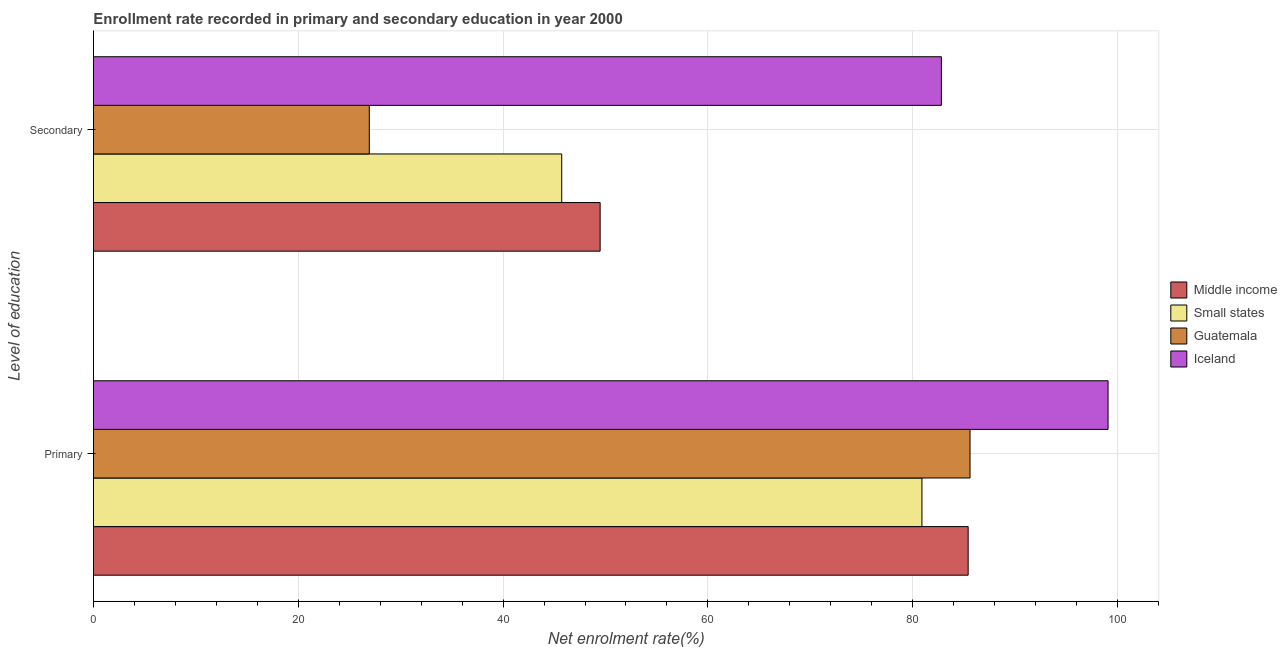Are the number of bars per tick equal to the number of legend labels?
Provide a short and direct response. Yes. Are the number of bars on each tick of the Y-axis equal?
Your response must be concise. Yes. What is the label of the 1st group of bars from the top?
Your answer should be very brief. Secondary. What is the enrollment rate in primary education in Guatemala?
Offer a very short reply. 85.6. Across all countries, what is the maximum enrollment rate in primary education?
Ensure brevity in your answer.  99.08. Across all countries, what is the minimum enrollment rate in primary education?
Make the answer very short. 80.9. In which country was the enrollment rate in secondary education minimum?
Offer a very short reply. Guatemala. What is the total enrollment rate in primary education in the graph?
Provide a succinct answer. 350.99. What is the difference between the enrollment rate in primary education in Small states and that in Iceland?
Offer a terse response. -18.17. What is the difference between the enrollment rate in secondary education in Middle income and the enrollment rate in primary education in Guatemala?
Keep it short and to the point. -36.12. What is the average enrollment rate in primary education per country?
Give a very brief answer. 87.75. What is the difference between the enrollment rate in primary education and enrollment rate in secondary education in Middle income?
Make the answer very short. 35.94. What is the ratio of the enrollment rate in primary education in Small states to that in Guatemala?
Make the answer very short. 0.95. In how many countries, is the enrollment rate in secondary education greater than the average enrollment rate in secondary education taken over all countries?
Make the answer very short. 1. What does the 2nd bar from the bottom in Primary represents?
Your answer should be compact. Small states. How many bars are there?
Provide a short and direct response. 8. What is the difference between two consecutive major ticks on the X-axis?
Keep it short and to the point. 20. Are the values on the major ticks of X-axis written in scientific E-notation?
Provide a short and direct response. No. Does the graph contain any zero values?
Provide a succinct answer. No. How are the legend labels stacked?
Offer a terse response. Vertical. What is the title of the graph?
Offer a very short reply. Enrollment rate recorded in primary and secondary education in year 2000. Does "Kiribati" appear as one of the legend labels in the graph?
Make the answer very short. No. What is the label or title of the X-axis?
Provide a short and direct response. Net enrolment rate(%). What is the label or title of the Y-axis?
Ensure brevity in your answer.  Level of education. What is the Net enrolment rate(%) in Middle income in Primary?
Give a very brief answer. 85.41. What is the Net enrolment rate(%) of Small states in Primary?
Your response must be concise. 80.9. What is the Net enrolment rate(%) of Guatemala in Primary?
Your answer should be very brief. 85.6. What is the Net enrolment rate(%) in Iceland in Primary?
Offer a terse response. 99.08. What is the Net enrolment rate(%) in Middle income in Secondary?
Provide a short and direct response. 49.48. What is the Net enrolment rate(%) in Small states in Secondary?
Your answer should be compact. 45.72. What is the Net enrolment rate(%) in Guatemala in Secondary?
Provide a succinct answer. 26.94. What is the Net enrolment rate(%) in Iceland in Secondary?
Keep it short and to the point. 82.8. Across all Level of education, what is the maximum Net enrolment rate(%) in Middle income?
Keep it short and to the point. 85.41. Across all Level of education, what is the maximum Net enrolment rate(%) in Small states?
Your answer should be very brief. 80.9. Across all Level of education, what is the maximum Net enrolment rate(%) in Guatemala?
Ensure brevity in your answer.  85.6. Across all Level of education, what is the maximum Net enrolment rate(%) in Iceland?
Provide a short and direct response. 99.08. Across all Level of education, what is the minimum Net enrolment rate(%) of Middle income?
Give a very brief answer. 49.48. Across all Level of education, what is the minimum Net enrolment rate(%) of Small states?
Keep it short and to the point. 45.72. Across all Level of education, what is the minimum Net enrolment rate(%) of Guatemala?
Give a very brief answer. 26.94. Across all Level of education, what is the minimum Net enrolment rate(%) in Iceland?
Your answer should be very brief. 82.8. What is the total Net enrolment rate(%) of Middle income in the graph?
Your answer should be very brief. 134.89. What is the total Net enrolment rate(%) of Small states in the graph?
Your answer should be very brief. 126.63. What is the total Net enrolment rate(%) in Guatemala in the graph?
Offer a very short reply. 112.53. What is the total Net enrolment rate(%) in Iceland in the graph?
Offer a terse response. 181.88. What is the difference between the Net enrolment rate(%) of Middle income in Primary and that in Secondary?
Your response must be concise. 35.94. What is the difference between the Net enrolment rate(%) of Small states in Primary and that in Secondary?
Ensure brevity in your answer.  35.18. What is the difference between the Net enrolment rate(%) of Guatemala in Primary and that in Secondary?
Offer a terse response. 58.66. What is the difference between the Net enrolment rate(%) in Iceland in Primary and that in Secondary?
Offer a terse response. 16.28. What is the difference between the Net enrolment rate(%) of Middle income in Primary and the Net enrolment rate(%) of Small states in Secondary?
Your answer should be compact. 39.69. What is the difference between the Net enrolment rate(%) in Middle income in Primary and the Net enrolment rate(%) in Guatemala in Secondary?
Your answer should be very brief. 58.48. What is the difference between the Net enrolment rate(%) in Middle income in Primary and the Net enrolment rate(%) in Iceland in Secondary?
Your answer should be very brief. 2.61. What is the difference between the Net enrolment rate(%) in Small states in Primary and the Net enrolment rate(%) in Guatemala in Secondary?
Provide a succinct answer. 53.97. What is the difference between the Net enrolment rate(%) in Small states in Primary and the Net enrolment rate(%) in Iceland in Secondary?
Ensure brevity in your answer.  -1.9. What is the difference between the Net enrolment rate(%) in Guatemala in Primary and the Net enrolment rate(%) in Iceland in Secondary?
Keep it short and to the point. 2.8. What is the average Net enrolment rate(%) of Middle income per Level of education?
Provide a succinct answer. 67.45. What is the average Net enrolment rate(%) in Small states per Level of education?
Provide a short and direct response. 63.31. What is the average Net enrolment rate(%) of Guatemala per Level of education?
Ensure brevity in your answer.  56.27. What is the average Net enrolment rate(%) in Iceland per Level of education?
Ensure brevity in your answer.  90.94. What is the difference between the Net enrolment rate(%) of Middle income and Net enrolment rate(%) of Small states in Primary?
Give a very brief answer. 4.51. What is the difference between the Net enrolment rate(%) of Middle income and Net enrolment rate(%) of Guatemala in Primary?
Offer a terse response. -0.18. What is the difference between the Net enrolment rate(%) of Middle income and Net enrolment rate(%) of Iceland in Primary?
Make the answer very short. -13.66. What is the difference between the Net enrolment rate(%) of Small states and Net enrolment rate(%) of Guatemala in Primary?
Your response must be concise. -4.7. What is the difference between the Net enrolment rate(%) in Small states and Net enrolment rate(%) in Iceland in Primary?
Provide a succinct answer. -18.17. What is the difference between the Net enrolment rate(%) in Guatemala and Net enrolment rate(%) in Iceland in Primary?
Offer a terse response. -13.48. What is the difference between the Net enrolment rate(%) of Middle income and Net enrolment rate(%) of Small states in Secondary?
Give a very brief answer. 3.75. What is the difference between the Net enrolment rate(%) in Middle income and Net enrolment rate(%) in Guatemala in Secondary?
Offer a very short reply. 22.54. What is the difference between the Net enrolment rate(%) of Middle income and Net enrolment rate(%) of Iceland in Secondary?
Offer a terse response. -33.32. What is the difference between the Net enrolment rate(%) in Small states and Net enrolment rate(%) in Guatemala in Secondary?
Offer a terse response. 18.79. What is the difference between the Net enrolment rate(%) in Small states and Net enrolment rate(%) in Iceland in Secondary?
Provide a succinct answer. -37.08. What is the difference between the Net enrolment rate(%) of Guatemala and Net enrolment rate(%) of Iceland in Secondary?
Your response must be concise. -55.86. What is the ratio of the Net enrolment rate(%) of Middle income in Primary to that in Secondary?
Your response must be concise. 1.73. What is the ratio of the Net enrolment rate(%) of Small states in Primary to that in Secondary?
Offer a terse response. 1.77. What is the ratio of the Net enrolment rate(%) in Guatemala in Primary to that in Secondary?
Ensure brevity in your answer.  3.18. What is the ratio of the Net enrolment rate(%) in Iceland in Primary to that in Secondary?
Give a very brief answer. 1.2. What is the difference between the highest and the second highest Net enrolment rate(%) in Middle income?
Make the answer very short. 35.94. What is the difference between the highest and the second highest Net enrolment rate(%) in Small states?
Your answer should be compact. 35.18. What is the difference between the highest and the second highest Net enrolment rate(%) in Guatemala?
Make the answer very short. 58.66. What is the difference between the highest and the second highest Net enrolment rate(%) of Iceland?
Offer a very short reply. 16.28. What is the difference between the highest and the lowest Net enrolment rate(%) of Middle income?
Offer a terse response. 35.94. What is the difference between the highest and the lowest Net enrolment rate(%) in Small states?
Your response must be concise. 35.18. What is the difference between the highest and the lowest Net enrolment rate(%) in Guatemala?
Your answer should be very brief. 58.66. What is the difference between the highest and the lowest Net enrolment rate(%) in Iceland?
Give a very brief answer. 16.28. 